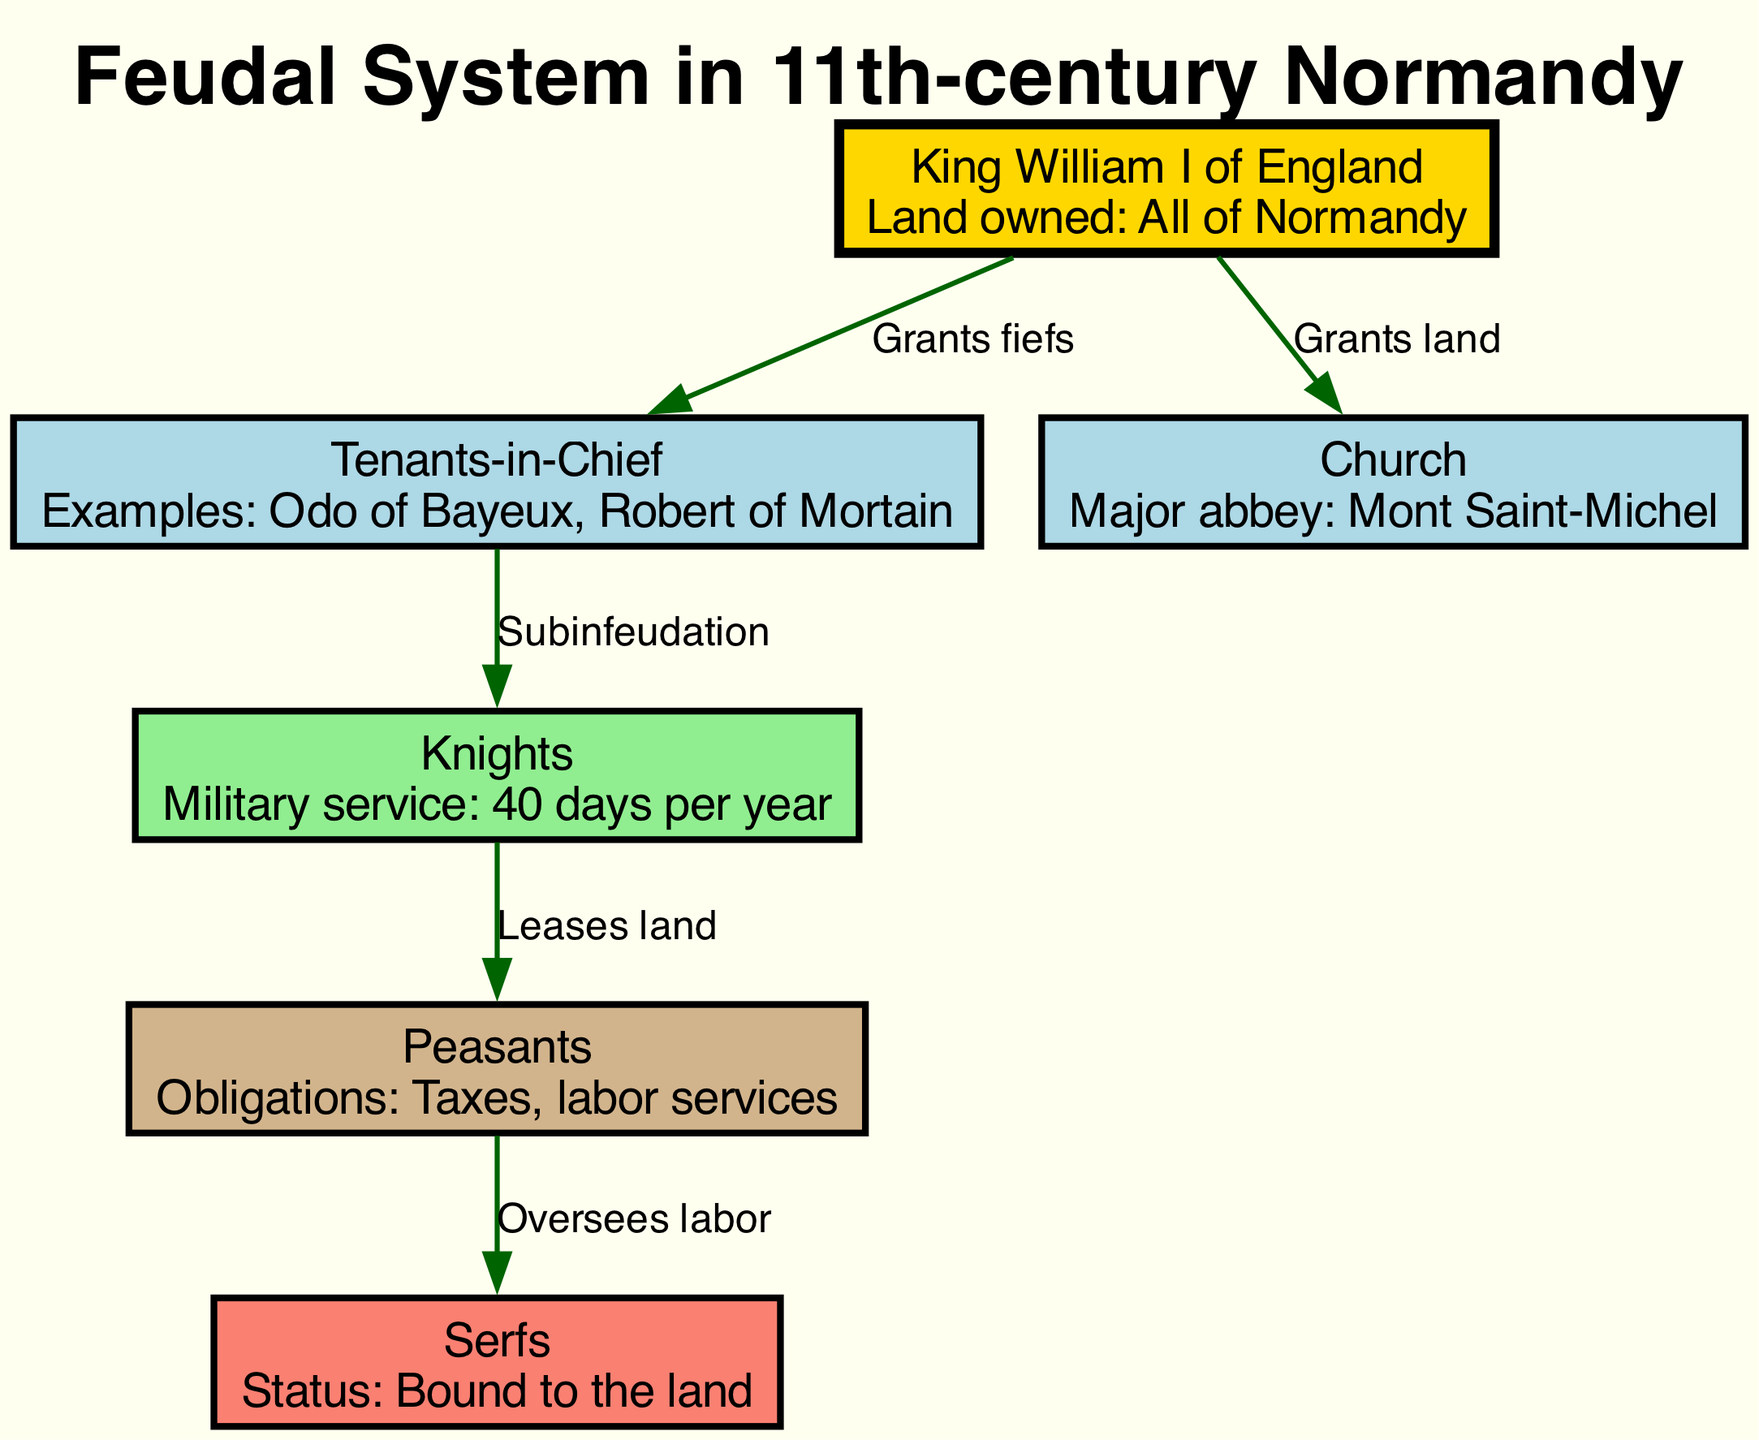What is the top node in the diagram? The top node in the diagram represents King William I of England, who is the highest authority in the feudal system. This can be identified as he is shown at the topmost position, connecting to other nodes.
Answer: King William I of England How many main nodes are there in the diagram? The diagram consists of six main nodes: King William I of England, Tenants-in-Chief, Church, Knights, Peasants, and Serfs. This can be determined by counting each unique node represented visually.
Answer: Six What relationship exists between the "King" and the "Tenants-in-Chief"? The relationship is indicated by the edge labeled "Grants fiefs," showing that the King provides land (fiefs) to the Tenants-in-Chief for their use. This direct connection illustrates the flow of power and land distribution.
Answer: Grants fiefs Who is responsible for overseeing labor according to the diagram? The Peasants oversee the labor of the Serfs, as shown by the edge labeled "Oversees labor" connecting Peasants to Serfs. This denotes a managerial role of the Peasants over those who are bound to the land.
Answer: Peasants What is the primary obligation of the Knights? The diagram states that Knights have a military service obligation of 40 days per year, which is specified under their node's properties. This direct information indicates the duties expected from this class of the feudal system.
Answer: 40 days per year What does the Tenants-in-Chief provide to the Knights? The Tenants-in-Chief provide Subinfeudation to the Knights, meaning they grant portions of their fiefs to the Knights for further management and service. This can be inferred from the connecting labeled edge in the diagram.
Answer: Subinfeudation Which group has the lowest social status in the diagram? The Serfs hold the lowest social status, as indicated in their description stating "Status: Bound to the land." This implies their lack of rights and mobility compared to other groups.
Answer: Serfs What major abbey is associated with the Church in the diagram? The major abbey associated with the Church, as specified in the properties, is Mont Saint-Michel. This indicates a significant religious and historical site, relevant to the context of the feudal system.
Answer: Mont Saint-Michel How do the Knights acquire land to lease? Knights acquire land to lease from the Tenants-in-Chief through the process of Subinfeudation. This relationship is depicted in the diagram demonstrating the hierarchical distribution of land among the different classes.
Answer: Subinfeudation 